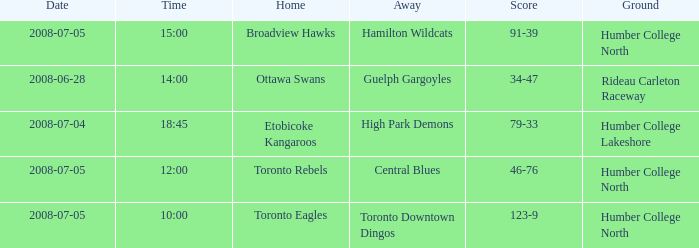Write the full table. {'header': ['Date', 'Time', 'Home', 'Away', 'Score', 'Ground'], 'rows': [['2008-07-05', '15:00', 'Broadview Hawks', 'Hamilton Wildcats', '91-39', 'Humber College North'], ['2008-06-28', '14:00', 'Ottawa Swans', 'Guelph Gargoyles', '34-47', 'Rideau Carleton Raceway'], ['2008-07-04', '18:45', 'Etobicoke Kangaroos', 'High Park Demons', '79-33', 'Humber College Lakeshore'], ['2008-07-05', '12:00', 'Toronto Rebels', 'Central Blues', '46-76', 'Humber College North'], ['2008-07-05', '10:00', 'Toronto Eagles', 'Toronto Downtown Dingos', '123-9', 'Humber College North']]} What is the Score with a Date that is 2008-06-28? 34-47. 